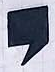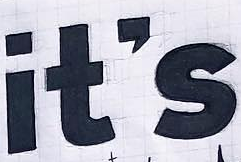Transcribe the words shown in these images in order, separated by a semicolon. ,; it's 